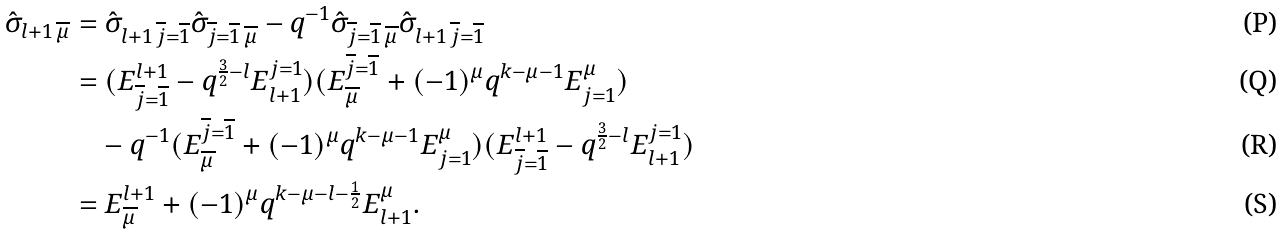<formula> <loc_0><loc_0><loc_500><loc_500>\hat { \sigma } _ { l + 1 \, \overline { \mu } } & = \hat { \sigma } _ { l + 1 \, \overline { j } = \overline { 1 } } \hat { \sigma } _ { \overline { j } = \overline { 1 } \, \overline { \mu } } - q ^ { - 1 } \hat { \sigma } _ { \overline { j } = \overline { 1 } \, \overline { \mu } } \hat { \sigma } _ { l + 1 \, \overline { j } = \overline { 1 } } \\ & = ( E ^ { l + 1 } _ { \overline { j } = \overline { 1 } } - q ^ { \frac { 3 } { 2 } - l } E ^ { j = 1 } _ { l + 1 } ) ( E ^ { \overline { j } = \overline { 1 } } _ { \overline { \mu } } + ( - 1 ) ^ { \mu } q ^ { k - \mu - 1 } E ^ { \mu } _ { j = 1 } ) \\ & \quad - q ^ { - 1 } ( E ^ { \overline { j } = \overline { 1 } } _ { \overline { \mu } } + ( - 1 ) ^ { \mu } q ^ { k - \mu - 1 } E ^ { \mu } _ { j = 1 } ) ( E ^ { l + 1 } _ { \overline { j } = \overline { 1 } } - q ^ { \frac { 3 } { 2 } - l } E ^ { j = 1 } _ { l + 1 } ) \\ & = E ^ { l + 1 } _ { \overline { \mu } } + ( - 1 ) ^ { \mu } q ^ { k - \mu - l - \frac { 1 } { 2 } } E ^ { \mu } _ { l + 1 } .</formula> 